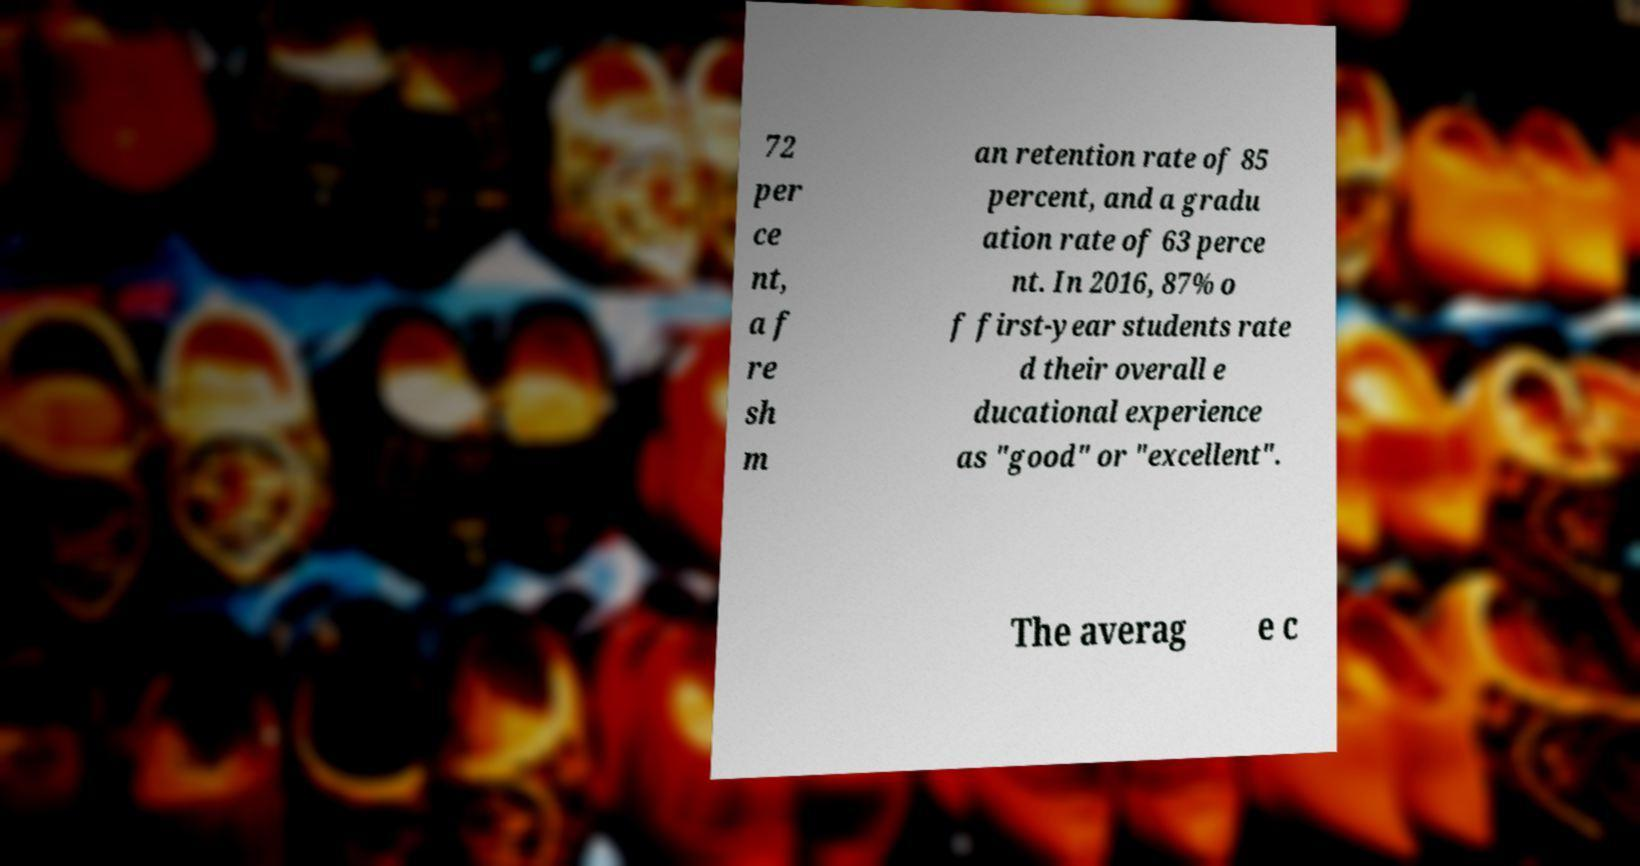What messages or text are displayed in this image? I need them in a readable, typed format. 72 per ce nt, a f re sh m an retention rate of 85 percent, and a gradu ation rate of 63 perce nt. In 2016, 87% o f first-year students rate d their overall e ducational experience as "good" or "excellent". The averag e c 